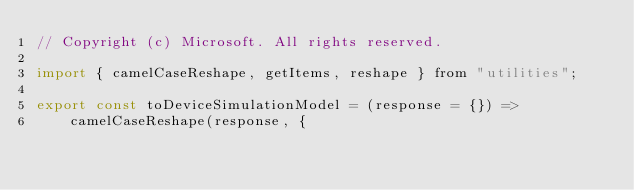<code> <loc_0><loc_0><loc_500><loc_500><_JavaScript_>// Copyright (c) Microsoft. All rights reserved.

import { camelCaseReshape, getItems, reshape } from "utilities";

export const toDeviceSimulationModel = (response = {}) =>
    camelCaseReshape(response, {</code> 